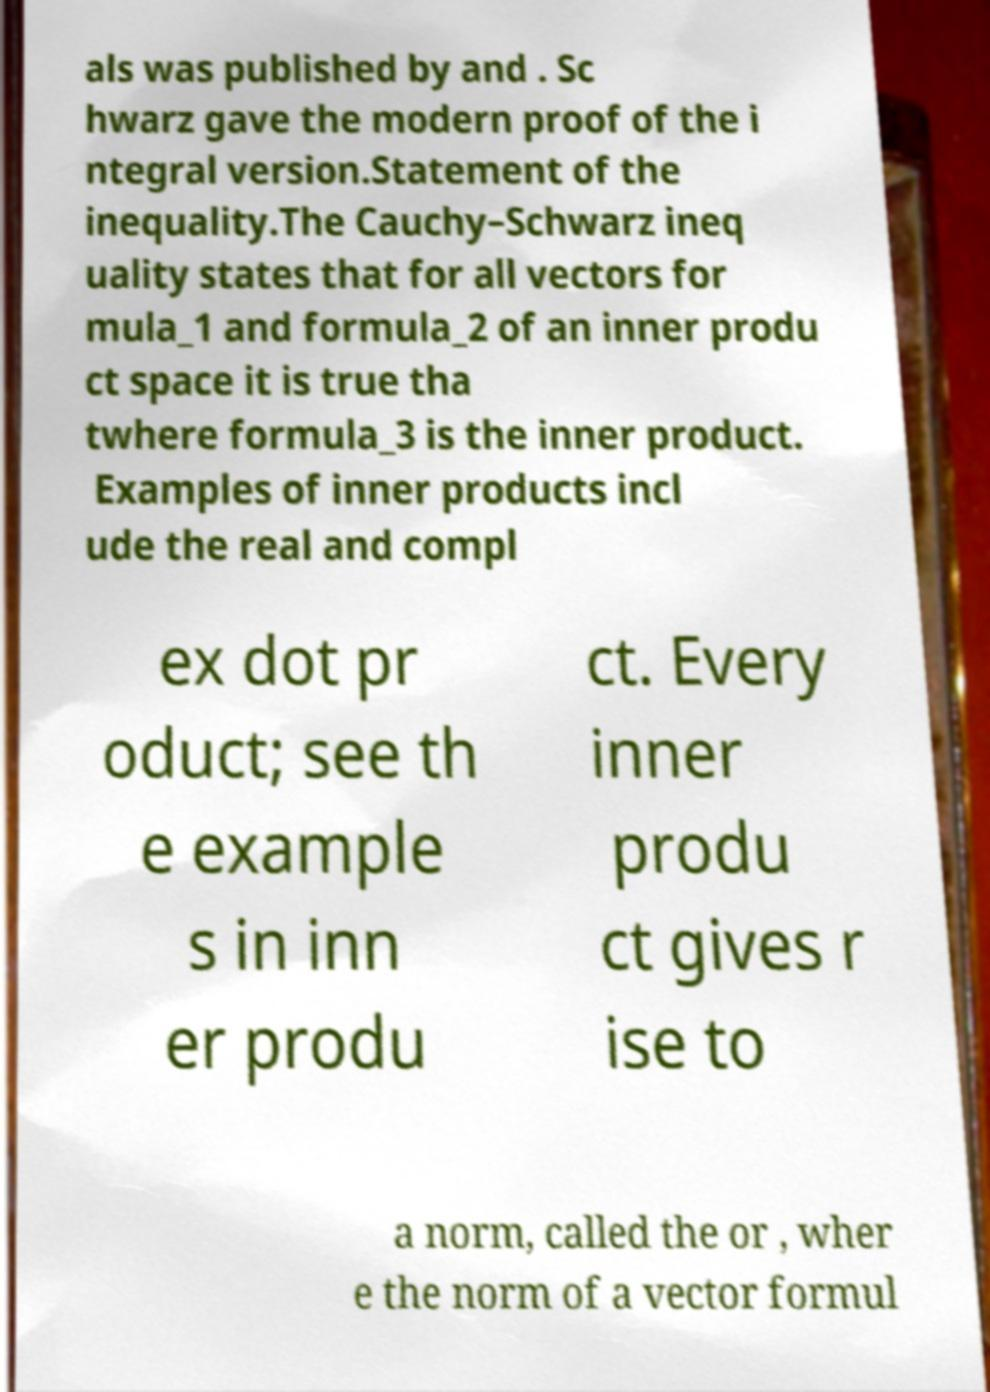There's text embedded in this image that I need extracted. Can you transcribe it verbatim? als was published by and . Sc hwarz gave the modern proof of the i ntegral version.Statement of the inequality.The Cauchy–Schwarz ineq uality states that for all vectors for mula_1 and formula_2 of an inner produ ct space it is true tha twhere formula_3 is the inner product. Examples of inner products incl ude the real and compl ex dot pr oduct; see th e example s in inn er produ ct. Every inner produ ct gives r ise to a norm, called the or , wher e the norm of a vector formul 